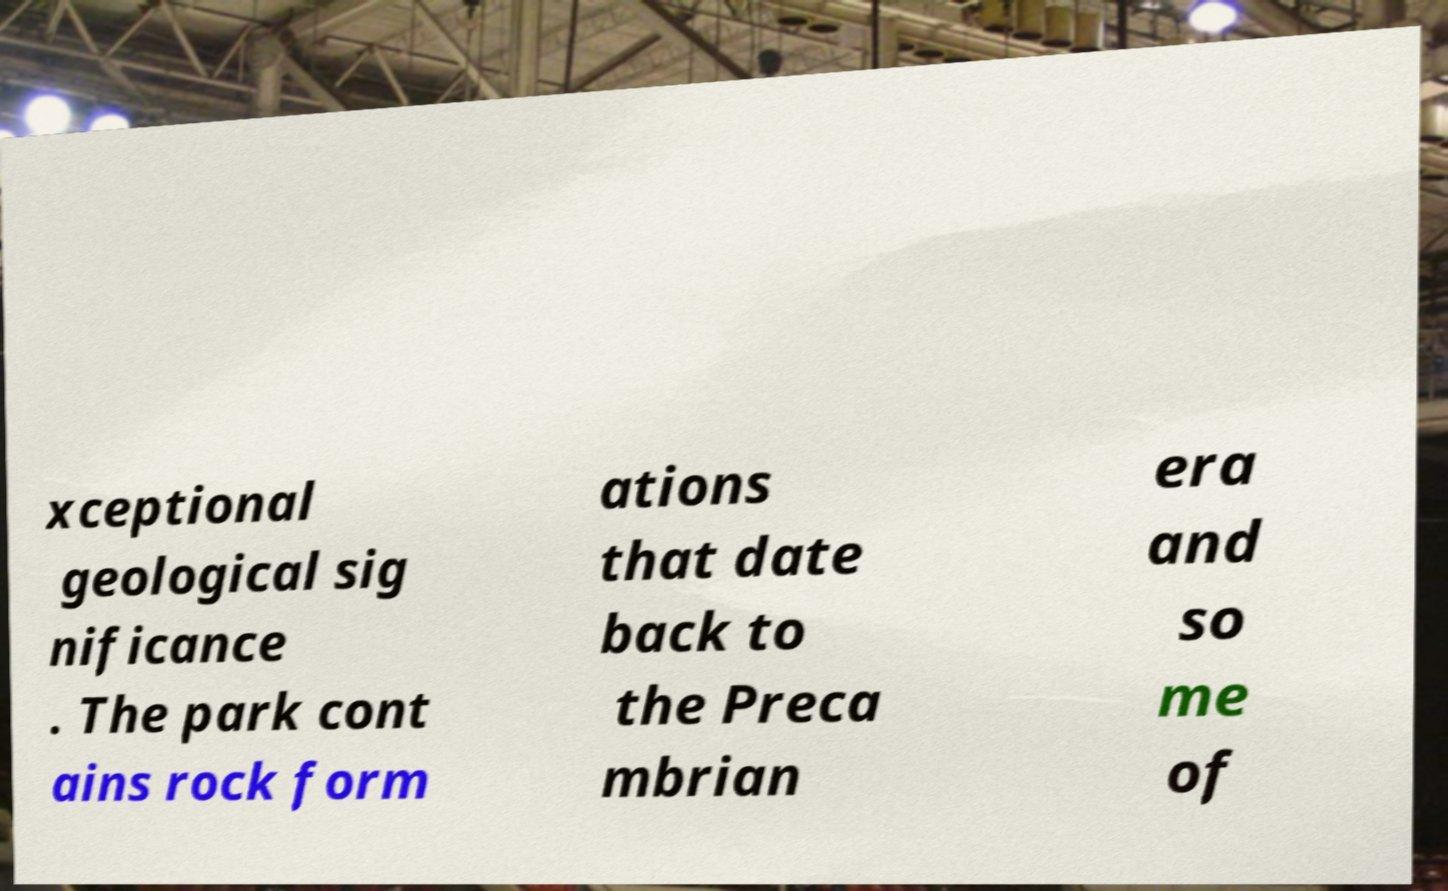Can you read and provide the text displayed in the image?This photo seems to have some interesting text. Can you extract and type it out for me? xceptional geological sig nificance . The park cont ains rock form ations that date back to the Preca mbrian era and so me of 